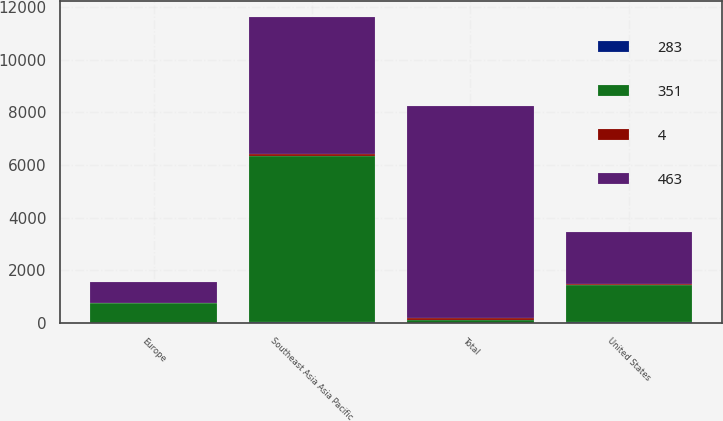Convert chart to OTSL. <chart><loc_0><loc_0><loc_500><loc_500><stacked_bar_chart><ecel><fcel>Southeast Asia Asia Pacific<fcel>United States<fcel>Europe<fcel>Total<nl><fcel>351<fcel>6312<fcel>1419<fcel>735<fcel>100<nl><fcel>4<fcel>75<fcel>17<fcel>8<fcel>100<nl><fcel>283<fcel>21<fcel>29<fcel>10<fcel>5<nl><fcel>463<fcel>5225<fcel>1995<fcel>817<fcel>8037<nl></chart> 